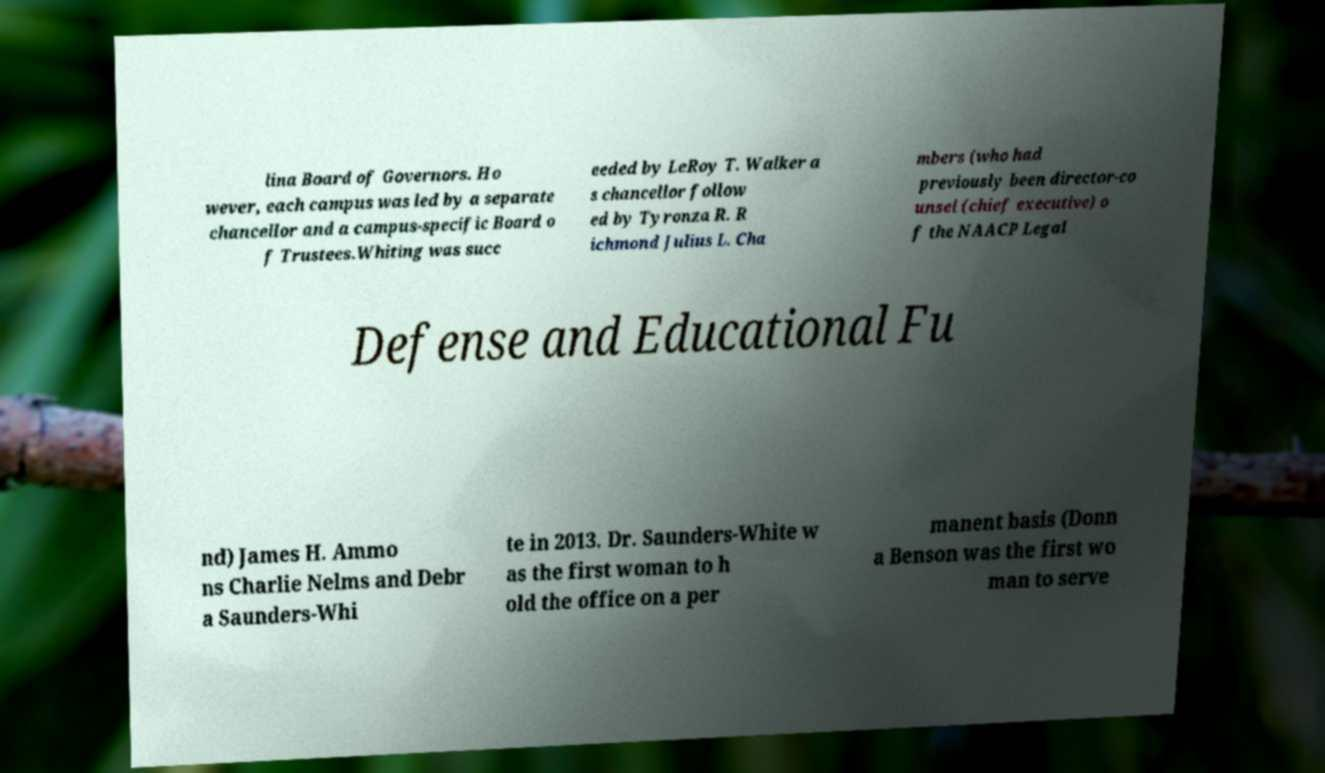For documentation purposes, I need the text within this image transcribed. Could you provide that? lina Board of Governors. Ho wever, each campus was led by a separate chancellor and a campus-specific Board o f Trustees.Whiting was succ eeded by LeRoy T. Walker a s chancellor follow ed by Tyronza R. R ichmond Julius L. Cha mbers (who had previously been director-co unsel (chief executive) o f the NAACP Legal Defense and Educational Fu nd) James H. Ammo ns Charlie Nelms and Debr a Saunders-Whi te in 2013. Dr. Saunders-White w as the first woman to h old the office on a per manent basis (Donn a Benson was the first wo man to serve 